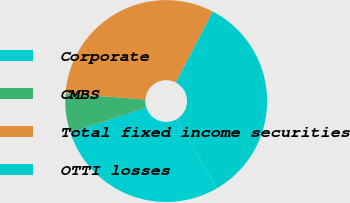<chart> <loc_0><loc_0><loc_500><loc_500><pie_chart><fcel>Corporate<fcel>CMBS<fcel>Total fixed income securities<fcel>OTTI losses<nl><fcel>28.3%<fcel>6.29%<fcel>31.45%<fcel>33.96%<nl></chart> 